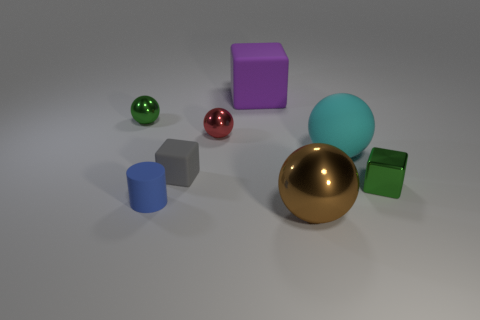Subtract all tiny green cubes. How many cubes are left? 2 Subtract all purple cubes. How many cubes are left? 2 Subtract 1 cylinders. How many cylinders are left? 0 Subtract all cylinders. How many objects are left? 7 Add 1 tiny spheres. How many objects exist? 9 Subtract all cyan spheres. How many green blocks are left? 1 Subtract all red objects. Subtract all red objects. How many objects are left? 6 Add 3 blue things. How many blue things are left? 4 Add 8 tiny cubes. How many tiny cubes exist? 10 Subtract 0 brown blocks. How many objects are left? 8 